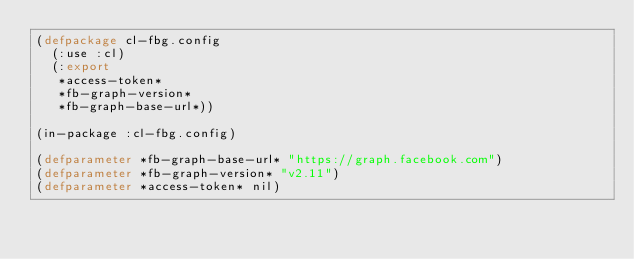Convert code to text. <code><loc_0><loc_0><loc_500><loc_500><_Lisp_>(defpackage cl-fbg.config
  (:use :cl)
  (:export
   *access-token*
   *fb-graph-version*
   *fb-graph-base-url*))

(in-package :cl-fbg.config)

(defparameter *fb-graph-base-url* "https://graph.facebook.com")
(defparameter *fb-graph-version* "v2.11")
(defparameter *access-token* nil)
</code> 